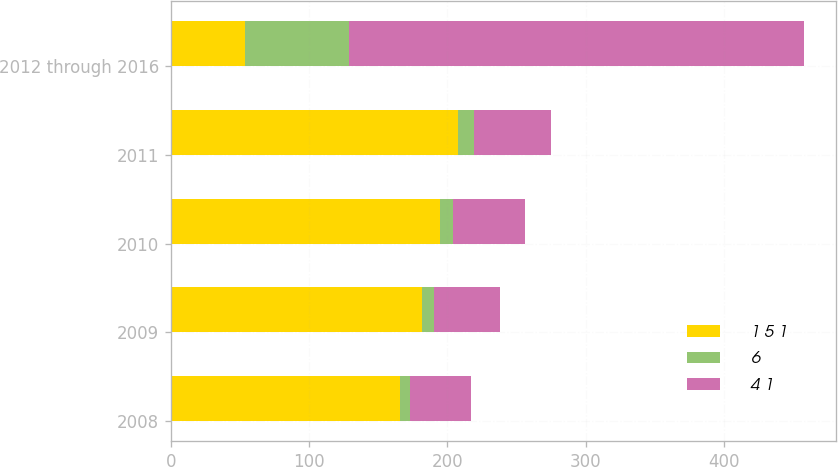<chart> <loc_0><loc_0><loc_500><loc_500><stacked_bar_chart><ecel><fcel>2008<fcel>2009<fcel>2010<fcel>2011<fcel>2012 through 2016<nl><fcel>1 5 1<fcel>166<fcel>182<fcel>195<fcel>208<fcel>54<nl><fcel>6<fcel>7<fcel>8<fcel>9<fcel>11<fcel>75<nl><fcel>4 1<fcel>44<fcel>48<fcel>52<fcel>56<fcel>329<nl></chart> 